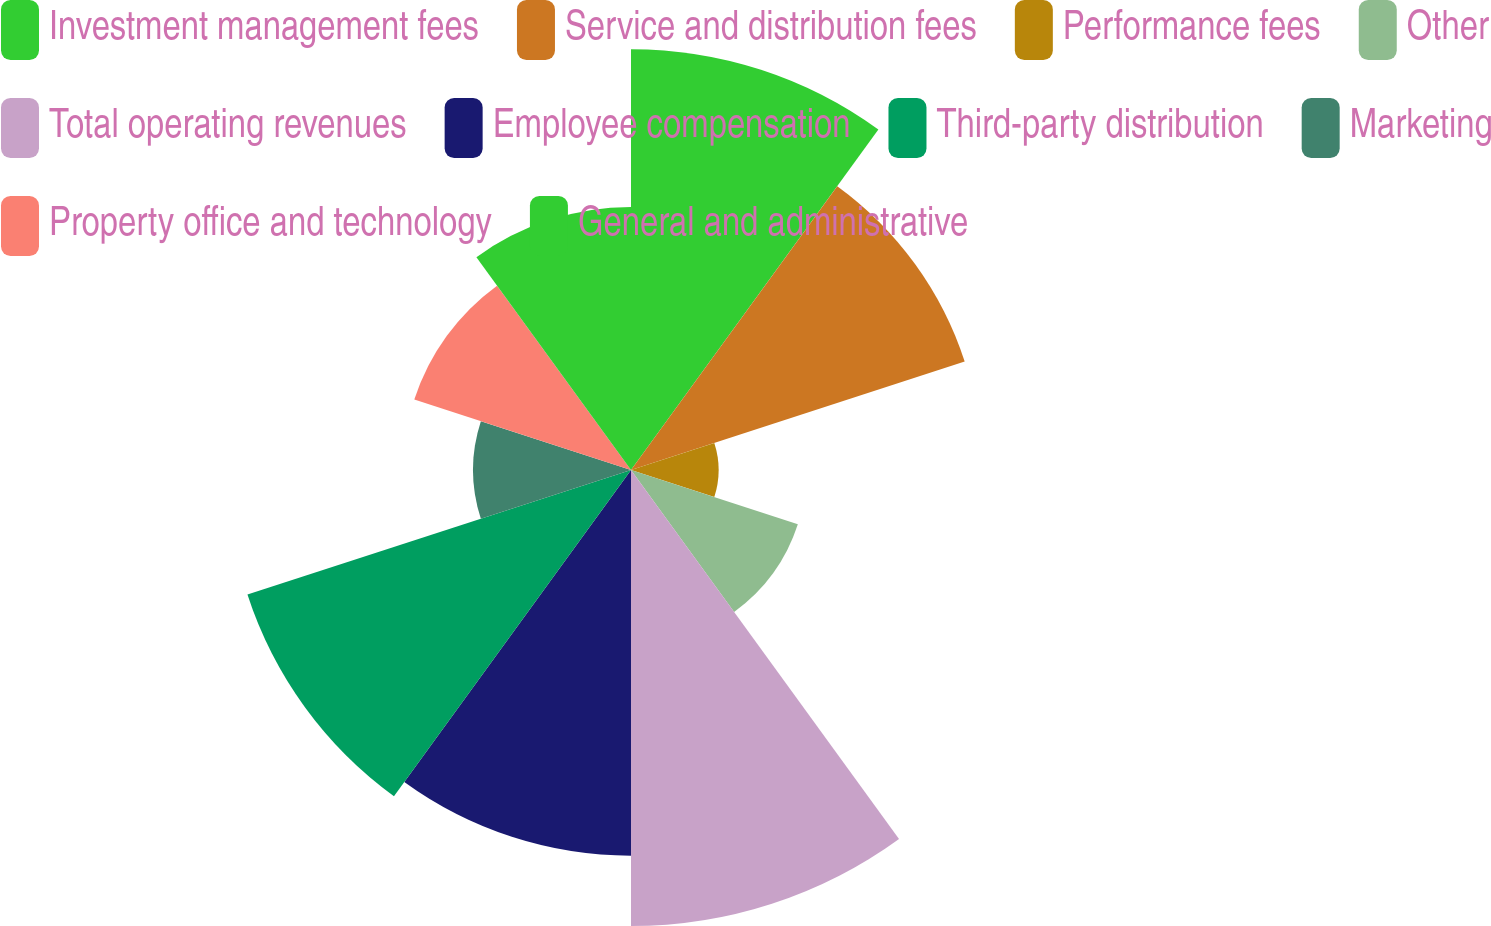<chart> <loc_0><loc_0><loc_500><loc_500><pie_chart><fcel>Investment management fees<fcel>Service and distribution fees<fcel>Performance fees<fcel>Other<fcel>Total operating revenues<fcel>Employee compensation<fcel>Third-party distribution<fcel>Marketing<fcel>Property office and technology<fcel>General and administrative<nl><fcel>14.37%<fcel>11.98%<fcel>2.99%<fcel>5.99%<fcel>15.57%<fcel>13.17%<fcel>13.77%<fcel>5.39%<fcel>7.78%<fcel>8.98%<nl></chart> 